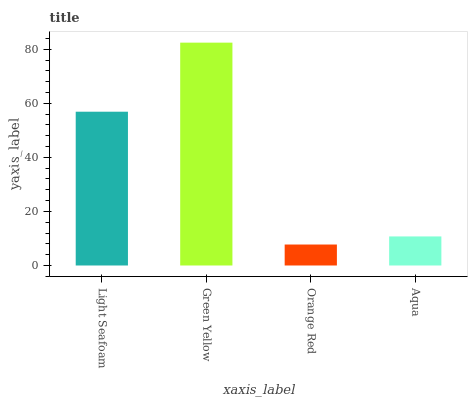Is Orange Red the minimum?
Answer yes or no. Yes. Is Green Yellow the maximum?
Answer yes or no. Yes. Is Green Yellow the minimum?
Answer yes or no. No. Is Orange Red the maximum?
Answer yes or no. No. Is Green Yellow greater than Orange Red?
Answer yes or no. Yes. Is Orange Red less than Green Yellow?
Answer yes or no. Yes. Is Orange Red greater than Green Yellow?
Answer yes or no. No. Is Green Yellow less than Orange Red?
Answer yes or no. No. Is Light Seafoam the high median?
Answer yes or no. Yes. Is Aqua the low median?
Answer yes or no. Yes. Is Orange Red the high median?
Answer yes or no. No. Is Light Seafoam the low median?
Answer yes or no. No. 